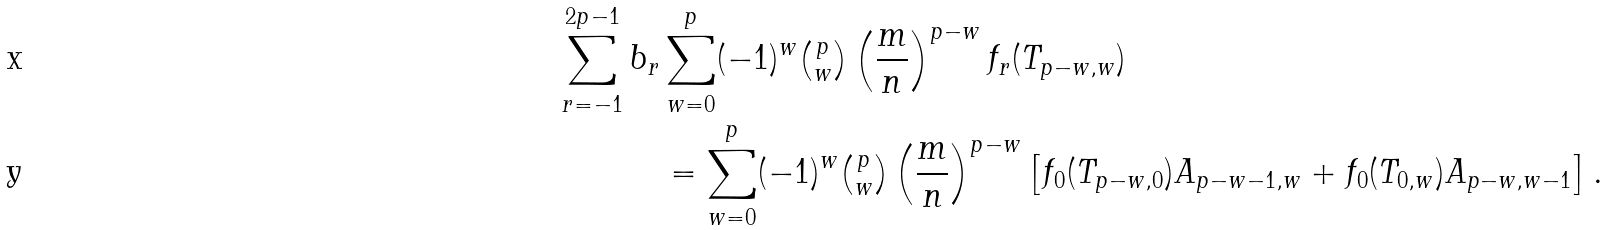Convert formula to latex. <formula><loc_0><loc_0><loc_500><loc_500>\sum _ { r = - 1 } ^ { 2 p - 1 } b _ { r } & \sum _ { w = 0 } ^ { p } ( - 1 ) ^ { w } \tbinom p w \left ( \frac { m } { n } \right ) ^ { p - w } f _ { r } ( T _ { p - w , w } ) \\ & = \sum _ { w = 0 } ^ { p } ( - 1 ) ^ { w } \tbinom p w \left ( \frac { m } { n } \right ) ^ { p - w } \left [ f _ { 0 } ( T _ { p - w , 0 } ) A _ { p - w - 1 , w } + f _ { 0 } ( T _ { 0 , w } ) A _ { p - w , w - 1 } \right ] .</formula> 